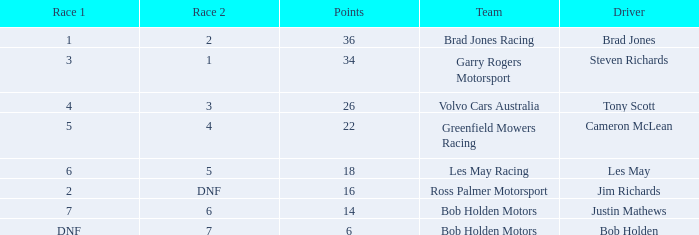Which driver for Greenfield Mowers Racing has fewer than 36 points? Cameron McLean. 